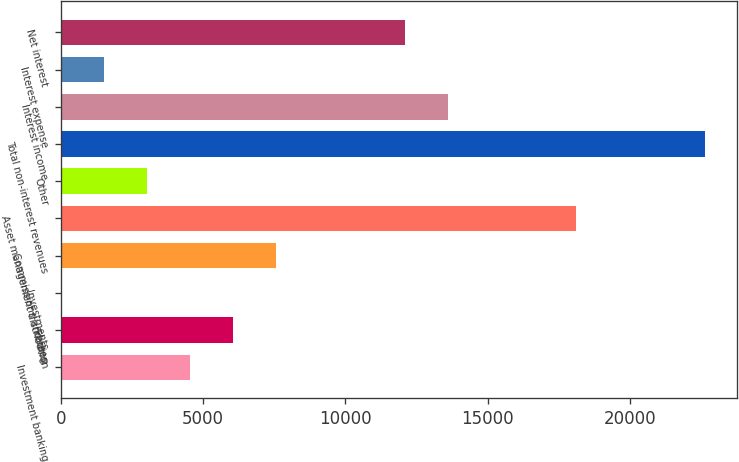<chart> <loc_0><loc_0><loc_500><loc_500><bar_chart><fcel>Investment banking<fcel>Trading<fcel>Investments<fcel>Commissions and fees<fcel>Asset management distribution<fcel>Other<fcel>Total non-interest revenues<fcel>Interest income<fcel>Interest expense<fcel>Net interest<nl><fcel>4542.6<fcel>6050.8<fcel>18<fcel>7559<fcel>18116.4<fcel>3034.4<fcel>22641<fcel>13591.8<fcel>1526.2<fcel>12083.6<nl></chart> 